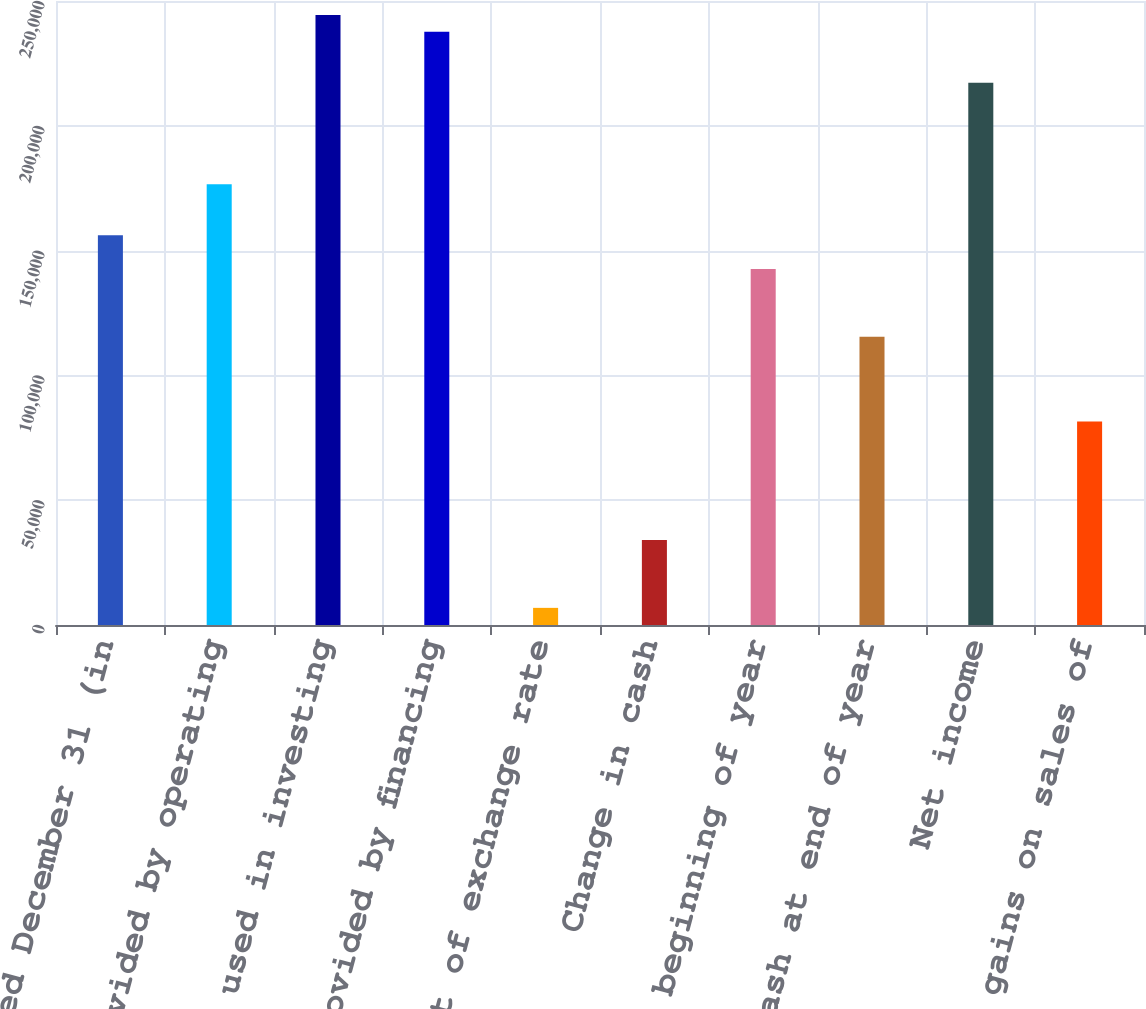Convert chart to OTSL. <chart><loc_0><loc_0><loc_500><loc_500><bar_chart><fcel>Years Ended December 31 (in<fcel>Net cash provided by operating<fcel>Net cash used in investing<fcel>Net cash provided by financing<fcel>Effect of exchange rate<fcel>Change in cash<fcel>Cash at beginning of year<fcel>Cash at end of year<fcel>Net income<fcel>Net gains on sales of<nl><fcel>156190<fcel>176552<fcel>244427<fcel>237640<fcel>6864.5<fcel>34014.5<fcel>142614<fcel>115464<fcel>217277<fcel>81527<nl></chart> 